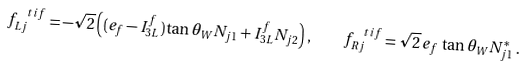Convert formula to latex. <formula><loc_0><loc_0><loc_500><loc_500>f _ { L j } ^ { \, \ t i f } = - \sqrt { 2 } \left ( ( e _ { f } - I _ { 3 L } ^ { f } ) \tan \theta _ { W } N _ { j 1 } + I _ { 3 L } ^ { f } N _ { j 2 } \right ) , \quad f _ { R j } ^ { \, \ t i f } = \sqrt { 2 } \, e _ { f } \, \tan \theta _ { W } N _ { j 1 } ^ { * } \, .</formula> 